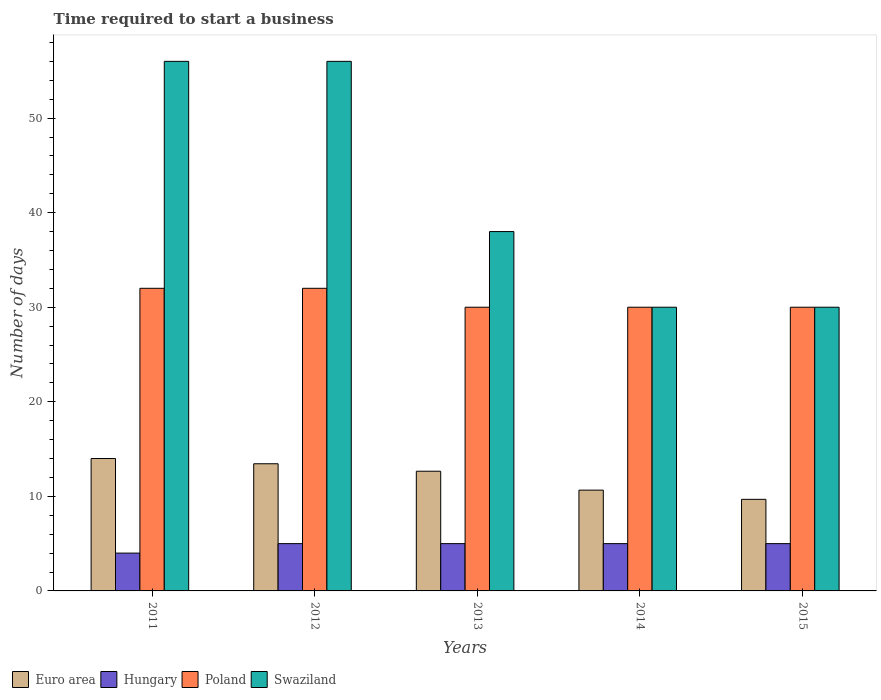Are the number of bars on each tick of the X-axis equal?
Your answer should be compact. Yes. How many bars are there on the 1st tick from the right?
Offer a very short reply. 4. What is the label of the 3rd group of bars from the left?
Give a very brief answer. 2013. Across all years, what is the minimum number of days required to start a business in Euro area?
Provide a succinct answer. 9.68. In which year was the number of days required to start a business in Swaziland maximum?
Give a very brief answer. 2011. In which year was the number of days required to start a business in Poland minimum?
Provide a succinct answer. 2013. What is the total number of days required to start a business in Poland in the graph?
Ensure brevity in your answer.  154. What is the difference between the number of days required to start a business in Poland in 2012 and that in 2014?
Provide a short and direct response. 2. What is the difference between the number of days required to start a business in Hungary in 2011 and the number of days required to start a business in Swaziland in 2014?
Ensure brevity in your answer.  -26. What is the average number of days required to start a business in Euro area per year?
Your response must be concise. 12.09. In the year 2011, what is the difference between the number of days required to start a business in Hungary and number of days required to start a business in Poland?
Provide a short and direct response. -28. What is the ratio of the number of days required to start a business in Euro area in 2013 to that in 2015?
Offer a very short reply. 1.31. Is the difference between the number of days required to start a business in Hungary in 2012 and 2015 greater than the difference between the number of days required to start a business in Poland in 2012 and 2015?
Provide a succinct answer. No. What is the difference between the highest and the second highest number of days required to start a business in Poland?
Offer a very short reply. 0. What is the difference between the highest and the lowest number of days required to start a business in Poland?
Your answer should be very brief. 2. In how many years, is the number of days required to start a business in Poland greater than the average number of days required to start a business in Poland taken over all years?
Provide a short and direct response. 2. Is the sum of the number of days required to start a business in Hungary in 2012 and 2015 greater than the maximum number of days required to start a business in Euro area across all years?
Provide a succinct answer. No. What does the 1st bar from the left in 2011 represents?
Ensure brevity in your answer.  Euro area. What does the 3rd bar from the right in 2011 represents?
Make the answer very short. Hungary. Is it the case that in every year, the sum of the number of days required to start a business in Euro area and number of days required to start a business in Swaziland is greater than the number of days required to start a business in Poland?
Offer a very short reply. Yes. How many bars are there?
Keep it short and to the point. 20. Does the graph contain any zero values?
Give a very brief answer. No. What is the title of the graph?
Your response must be concise. Time required to start a business. Does "Sierra Leone" appear as one of the legend labels in the graph?
Your answer should be very brief. No. What is the label or title of the X-axis?
Provide a short and direct response. Years. What is the label or title of the Y-axis?
Keep it short and to the point. Number of days. What is the Number of days in Hungary in 2011?
Make the answer very short. 4. What is the Number of days of Euro area in 2012?
Ensure brevity in your answer.  13.45. What is the Number of days of Hungary in 2012?
Your answer should be compact. 5. What is the Number of days in Poland in 2012?
Offer a terse response. 32. What is the Number of days of Euro area in 2013?
Offer a terse response. 12.66. What is the Number of days of Poland in 2013?
Keep it short and to the point. 30. What is the Number of days in Euro area in 2014?
Your response must be concise. 10.66. What is the Number of days of Swaziland in 2014?
Make the answer very short. 30. What is the Number of days of Euro area in 2015?
Keep it short and to the point. 9.68. What is the Number of days in Hungary in 2015?
Keep it short and to the point. 5. What is the Number of days in Poland in 2015?
Your response must be concise. 30. Across all years, what is the maximum Number of days in Poland?
Offer a terse response. 32. Across all years, what is the minimum Number of days of Euro area?
Make the answer very short. 9.68. Across all years, what is the minimum Number of days in Poland?
Offer a terse response. 30. What is the total Number of days in Euro area in the graph?
Your response must be concise. 60.45. What is the total Number of days of Hungary in the graph?
Your answer should be compact. 24. What is the total Number of days in Poland in the graph?
Ensure brevity in your answer.  154. What is the total Number of days of Swaziland in the graph?
Provide a short and direct response. 210. What is the difference between the Number of days in Euro area in 2011 and that in 2012?
Give a very brief answer. 0.55. What is the difference between the Number of days of Poland in 2011 and that in 2012?
Your response must be concise. 0. What is the difference between the Number of days in Euro area in 2011 and that in 2013?
Provide a short and direct response. 1.34. What is the difference between the Number of days in Hungary in 2011 and that in 2013?
Offer a terse response. -1. What is the difference between the Number of days of Euro area in 2011 and that in 2014?
Your answer should be compact. 3.34. What is the difference between the Number of days in Hungary in 2011 and that in 2014?
Offer a terse response. -1. What is the difference between the Number of days of Poland in 2011 and that in 2014?
Your answer should be very brief. 2. What is the difference between the Number of days in Swaziland in 2011 and that in 2014?
Provide a succinct answer. 26. What is the difference between the Number of days in Euro area in 2011 and that in 2015?
Make the answer very short. 4.32. What is the difference between the Number of days in Swaziland in 2011 and that in 2015?
Make the answer very short. 26. What is the difference between the Number of days of Euro area in 2012 and that in 2013?
Your response must be concise. 0.79. What is the difference between the Number of days of Euro area in 2012 and that in 2014?
Your answer should be compact. 2.79. What is the difference between the Number of days of Poland in 2012 and that in 2014?
Your answer should be compact. 2. What is the difference between the Number of days of Euro area in 2012 and that in 2015?
Make the answer very short. 3.76. What is the difference between the Number of days of Swaziland in 2012 and that in 2015?
Give a very brief answer. 26. What is the difference between the Number of days in Hungary in 2013 and that in 2014?
Offer a terse response. 0. What is the difference between the Number of days in Poland in 2013 and that in 2014?
Your answer should be very brief. 0. What is the difference between the Number of days of Euro area in 2013 and that in 2015?
Give a very brief answer. 2.97. What is the difference between the Number of days of Hungary in 2013 and that in 2015?
Ensure brevity in your answer.  0. What is the difference between the Number of days of Poland in 2013 and that in 2015?
Offer a very short reply. 0. What is the difference between the Number of days of Euro area in 2014 and that in 2015?
Your response must be concise. 0.97. What is the difference between the Number of days in Hungary in 2014 and that in 2015?
Your answer should be very brief. 0. What is the difference between the Number of days of Euro area in 2011 and the Number of days of Hungary in 2012?
Keep it short and to the point. 9. What is the difference between the Number of days of Euro area in 2011 and the Number of days of Poland in 2012?
Keep it short and to the point. -18. What is the difference between the Number of days of Euro area in 2011 and the Number of days of Swaziland in 2012?
Give a very brief answer. -42. What is the difference between the Number of days of Hungary in 2011 and the Number of days of Swaziland in 2012?
Give a very brief answer. -52. What is the difference between the Number of days of Euro area in 2011 and the Number of days of Poland in 2013?
Offer a very short reply. -16. What is the difference between the Number of days of Hungary in 2011 and the Number of days of Swaziland in 2013?
Ensure brevity in your answer.  -34. What is the difference between the Number of days of Euro area in 2011 and the Number of days of Hungary in 2014?
Offer a terse response. 9. What is the difference between the Number of days of Euro area in 2011 and the Number of days of Swaziland in 2014?
Make the answer very short. -16. What is the difference between the Number of days of Hungary in 2011 and the Number of days of Swaziland in 2014?
Your response must be concise. -26. What is the difference between the Number of days of Poland in 2011 and the Number of days of Swaziland in 2014?
Keep it short and to the point. 2. What is the difference between the Number of days of Euro area in 2011 and the Number of days of Poland in 2015?
Your answer should be very brief. -16. What is the difference between the Number of days in Hungary in 2011 and the Number of days in Swaziland in 2015?
Offer a very short reply. -26. What is the difference between the Number of days of Euro area in 2012 and the Number of days of Hungary in 2013?
Give a very brief answer. 8.45. What is the difference between the Number of days in Euro area in 2012 and the Number of days in Poland in 2013?
Provide a short and direct response. -16.55. What is the difference between the Number of days of Euro area in 2012 and the Number of days of Swaziland in 2013?
Provide a succinct answer. -24.55. What is the difference between the Number of days in Hungary in 2012 and the Number of days in Swaziland in 2013?
Keep it short and to the point. -33. What is the difference between the Number of days in Euro area in 2012 and the Number of days in Hungary in 2014?
Give a very brief answer. 8.45. What is the difference between the Number of days in Euro area in 2012 and the Number of days in Poland in 2014?
Provide a succinct answer. -16.55. What is the difference between the Number of days of Euro area in 2012 and the Number of days of Swaziland in 2014?
Offer a very short reply. -16.55. What is the difference between the Number of days in Poland in 2012 and the Number of days in Swaziland in 2014?
Give a very brief answer. 2. What is the difference between the Number of days of Euro area in 2012 and the Number of days of Hungary in 2015?
Keep it short and to the point. 8.45. What is the difference between the Number of days of Euro area in 2012 and the Number of days of Poland in 2015?
Offer a terse response. -16.55. What is the difference between the Number of days in Euro area in 2012 and the Number of days in Swaziland in 2015?
Provide a succinct answer. -16.55. What is the difference between the Number of days of Hungary in 2012 and the Number of days of Poland in 2015?
Your response must be concise. -25. What is the difference between the Number of days in Hungary in 2012 and the Number of days in Swaziland in 2015?
Keep it short and to the point. -25. What is the difference between the Number of days of Poland in 2012 and the Number of days of Swaziland in 2015?
Your response must be concise. 2. What is the difference between the Number of days in Euro area in 2013 and the Number of days in Hungary in 2014?
Keep it short and to the point. 7.66. What is the difference between the Number of days of Euro area in 2013 and the Number of days of Poland in 2014?
Provide a succinct answer. -17.34. What is the difference between the Number of days of Euro area in 2013 and the Number of days of Swaziland in 2014?
Your answer should be compact. -17.34. What is the difference between the Number of days in Hungary in 2013 and the Number of days in Swaziland in 2014?
Your answer should be very brief. -25. What is the difference between the Number of days in Poland in 2013 and the Number of days in Swaziland in 2014?
Keep it short and to the point. 0. What is the difference between the Number of days in Euro area in 2013 and the Number of days in Hungary in 2015?
Provide a succinct answer. 7.66. What is the difference between the Number of days of Euro area in 2013 and the Number of days of Poland in 2015?
Offer a very short reply. -17.34. What is the difference between the Number of days of Euro area in 2013 and the Number of days of Swaziland in 2015?
Your answer should be very brief. -17.34. What is the difference between the Number of days of Hungary in 2013 and the Number of days of Poland in 2015?
Offer a very short reply. -25. What is the difference between the Number of days in Poland in 2013 and the Number of days in Swaziland in 2015?
Keep it short and to the point. 0. What is the difference between the Number of days of Euro area in 2014 and the Number of days of Hungary in 2015?
Provide a succinct answer. 5.66. What is the difference between the Number of days in Euro area in 2014 and the Number of days in Poland in 2015?
Offer a terse response. -19.34. What is the difference between the Number of days of Euro area in 2014 and the Number of days of Swaziland in 2015?
Give a very brief answer. -19.34. What is the difference between the Number of days in Hungary in 2014 and the Number of days in Poland in 2015?
Give a very brief answer. -25. What is the difference between the Number of days in Poland in 2014 and the Number of days in Swaziland in 2015?
Your answer should be very brief. 0. What is the average Number of days of Euro area per year?
Your response must be concise. 12.09. What is the average Number of days of Hungary per year?
Offer a terse response. 4.8. What is the average Number of days of Poland per year?
Ensure brevity in your answer.  30.8. What is the average Number of days in Swaziland per year?
Give a very brief answer. 42. In the year 2011, what is the difference between the Number of days in Euro area and Number of days in Hungary?
Provide a succinct answer. 10. In the year 2011, what is the difference between the Number of days of Euro area and Number of days of Poland?
Your answer should be compact. -18. In the year 2011, what is the difference between the Number of days in Euro area and Number of days in Swaziland?
Keep it short and to the point. -42. In the year 2011, what is the difference between the Number of days in Hungary and Number of days in Poland?
Your answer should be compact. -28. In the year 2011, what is the difference between the Number of days of Hungary and Number of days of Swaziland?
Make the answer very short. -52. In the year 2012, what is the difference between the Number of days of Euro area and Number of days of Hungary?
Your answer should be very brief. 8.45. In the year 2012, what is the difference between the Number of days in Euro area and Number of days in Poland?
Make the answer very short. -18.55. In the year 2012, what is the difference between the Number of days of Euro area and Number of days of Swaziland?
Your answer should be compact. -42.55. In the year 2012, what is the difference between the Number of days in Hungary and Number of days in Swaziland?
Provide a short and direct response. -51. In the year 2013, what is the difference between the Number of days in Euro area and Number of days in Hungary?
Keep it short and to the point. 7.66. In the year 2013, what is the difference between the Number of days of Euro area and Number of days of Poland?
Keep it short and to the point. -17.34. In the year 2013, what is the difference between the Number of days of Euro area and Number of days of Swaziland?
Provide a short and direct response. -25.34. In the year 2013, what is the difference between the Number of days in Hungary and Number of days in Poland?
Your answer should be compact. -25. In the year 2013, what is the difference between the Number of days of Hungary and Number of days of Swaziland?
Make the answer very short. -33. In the year 2013, what is the difference between the Number of days in Poland and Number of days in Swaziland?
Your answer should be very brief. -8. In the year 2014, what is the difference between the Number of days in Euro area and Number of days in Hungary?
Make the answer very short. 5.66. In the year 2014, what is the difference between the Number of days of Euro area and Number of days of Poland?
Offer a very short reply. -19.34. In the year 2014, what is the difference between the Number of days in Euro area and Number of days in Swaziland?
Provide a short and direct response. -19.34. In the year 2014, what is the difference between the Number of days of Poland and Number of days of Swaziland?
Keep it short and to the point. 0. In the year 2015, what is the difference between the Number of days in Euro area and Number of days in Hungary?
Keep it short and to the point. 4.68. In the year 2015, what is the difference between the Number of days in Euro area and Number of days in Poland?
Your answer should be compact. -20.32. In the year 2015, what is the difference between the Number of days of Euro area and Number of days of Swaziland?
Offer a terse response. -20.32. In the year 2015, what is the difference between the Number of days of Hungary and Number of days of Swaziland?
Your answer should be very brief. -25. In the year 2015, what is the difference between the Number of days of Poland and Number of days of Swaziland?
Offer a very short reply. 0. What is the ratio of the Number of days of Euro area in 2011 to that in 2012?
Provide a short and direct response. 1.04. What is the ratio of the Number of days in Euro area in 2011 to that in 2013?
Your answer should be very brief. 1.11. What is the ratio of the Number of days of Hungary in 2011 to that in 2013?
Keep it short and to the point. 0.8. What is the ratio of the Number of days of Poland in 2011 to that in 2013?
Offer a very short reply. 1.07. What is the ratio of the Number of days of Swaziland in 2011 to that in 2013?
Provide a short and direct response. 1.47. What is the ratio of the Number of days in Euro area in 2011 to that in 2014?
Your answer should be compact. 1.31. What is the ratio of the Number of days of Poland in 2011 to that in 2014?
Give a very brief answer. 1.07. What is the ratio of the Number of days in Swaziland in 2011 to that in 2014?
Your response must be concise. 1.87. What is the ratio of the Number of days of Euro area in 2011 to that in 2015?
Offer a terse response. 1.45. What is the ratio of the Number of days of Hungary in 2011 to that in 2015?
Your response must be concise. 0.8. What is the ratio of the Number of days of Poland in 2011 to that in 2015?
Make the answer very short. 1.07. What is the ratio of the Number of days in Swaziland in 2011 to that in 2015?
Offer a terse response. 1.87. What is the ratio of the Number of days in Euro area in 2012 to that in 2013?
Offer a terse response. 1.06. What is the ratio of the Number of days of Poland in 2012 to that in 2013?
Ensure brevity in your answer.  1.07. What is the ratio of the Number of days in Swaziland in 2012 to that in 2013?
Your answer should be very brief. 1.47. What is the ratio of the Number of days in Euro area in 2012 to that in 2014?
Your answer should be compact. 1.26. What is the ratio of the Number of days in Poland in 2012 to that in 2014?
Keep it short and to the point. 1.07. What is the ratio of the Number of days in Swaziland in 2012 to that in 2014?
Provide a short and direct response. 1.87. What is the ratio of the Number of days in Euro area in 2012 to that in 2015?
Your response must be concise. 1.39. What is the ratio of the Number of days in Poland in 2012 to that in 2015?
Provide a short and direct response. 1.07. What is the ratio of the Number of days in Swaziland in 2012 to that in 2015?
Your response must be concise. 1.87. What is the ratio of the Number of days in Euro area in 2013 to that in 2014?
Give a very brief answer. 1.19. What is the ratio of the Number of days in Hungary in 2013 to that in 2014?
Ensure brevity in your answer.  1. What is the ratio of the Number of days of Swaziland in 2013 to that in 2014?
Offer a very short reply. 1.27. What is the ratio of the Number of days in Euro area in 2013 to that in 2015?
Make the answer very short. 1.31. What is the ratio of the Number of days of Hungary in 2013 to that in 2015?
Your answer should be compact. 1. What is the ratio of the Number of days of Poland in 2013 to that in 2015?
Offer a terse response. 1. What is the ratio of the Number of days of Swaziland in 2013 to that in 2015?
Make the answer very short. 1.27. What is the ratio of the Number of days of Euro area in 2014 to that in 2015?
Your answer should be very brief. 1.1. What is the ratio of the Number of days in Hungary in 2014 to that in 2015?
Your response must be concise. 1. What is the ratio of the Number of days of Swaziland in 2014 to that in 2015?
Offer a terse response. 1. What is the difference between the highest and the second highest Number of days in Euro area?
Offer a very short reply. 0.55. What is the difference between the highest and the second highest Number of days of Swaziland?
Provide a short and direct response. 0. What is the difference between the highest and the lowest Number of days in Euro area?
Give a very brief answer. 4.32. What is the difference between the highest and the lowest Number of days of Hungary?
Provide a short and direct response. 1. What is the difference between the highest and the lowest Number of days of Poland?
Provide a short and direct response. 2. What is the difference between the highest and the lowest Number of days in Swaziland?
Ensure brevity in your answer.  26. 